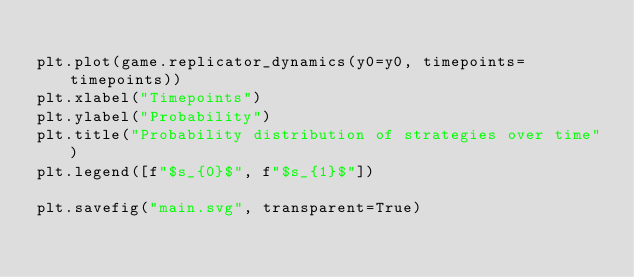Convert code to text. <code><loc_0><loc_0><loc_500><loc_500><_Python_>
plt.plot(game.replicator_dynamics(y0=y0, timepoints=timepoints))
plt.xlabel("Timepoints")
plt.ylabel("Probability")
plt.title("Probability distribution of strategies over time")
plt.legend([f"$s_{0}$", f"$s_{1}$"])

plt.savefig("main.svg", transparent=True)
</code> 